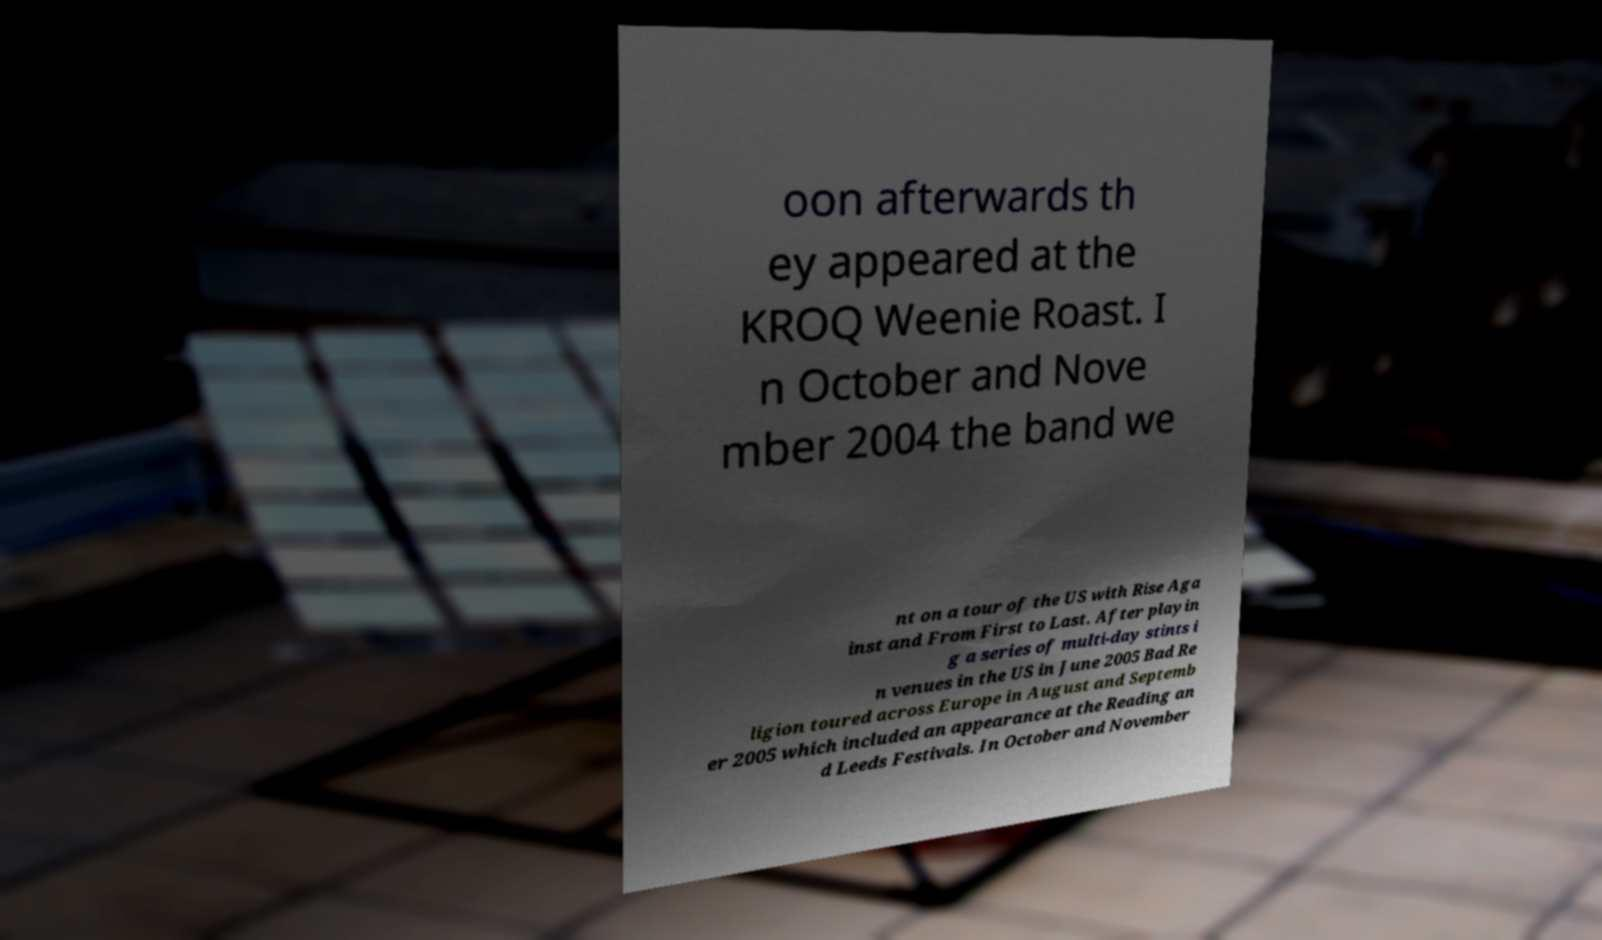Could you assist in decoding the text presented in this image and type it out clearly? oon afterwards th ey appeared at the KROQ Weenie Roast. I n October and Nove mber 2004 the band we nt on a tour of the US with Rise Aga inst and From First to Last. After playin g a series of multi-day stints i n venues in the US in June 2005 Bad Re ligion toured across Europe in August and Septemb er 2005 which included an appearance at the Reading an d Leeds Festivals. In October and November 